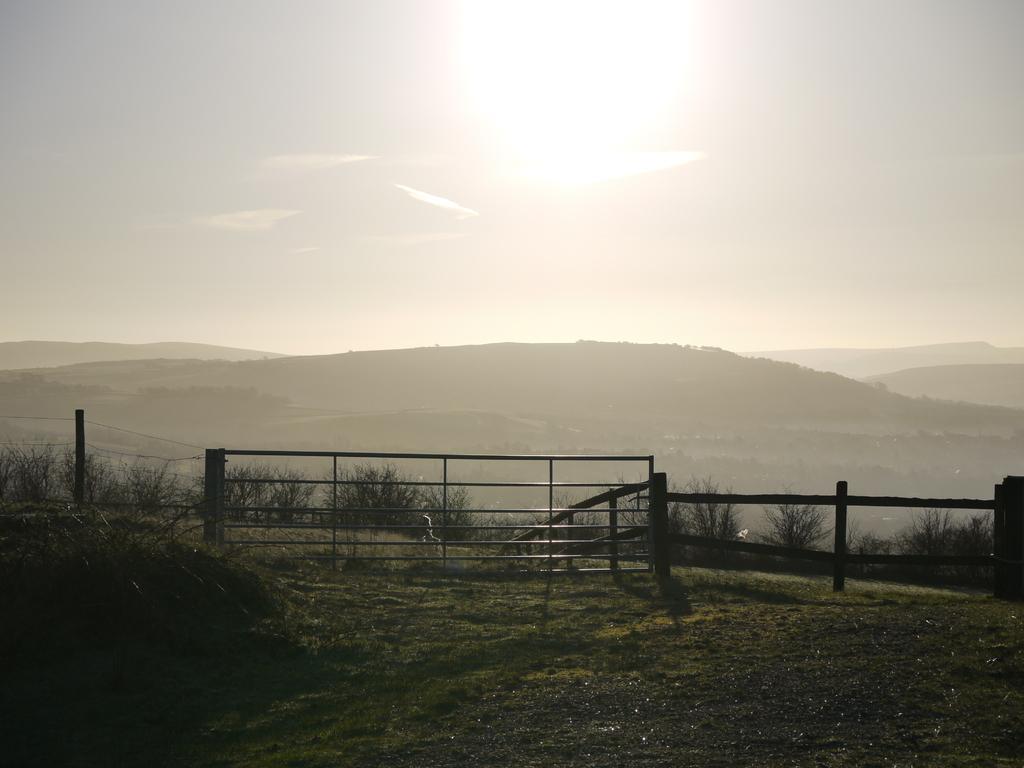Could you give a brief overview of what you see in this image? In this picture we can see a fence and person walking on the ground and in the background we can see grass, trees, sky. 